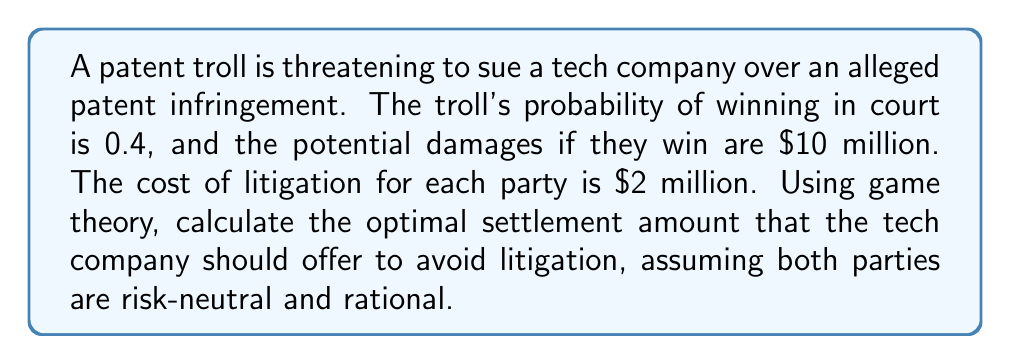Can you solve this math problem? Let's approach this step-by-step using game theory concepts:

1) First, we need to calculate the expected value of litigation for both parties:

   For the patent troll:
   $$ EV_{troll} = (0.4 \times \$10M) - \$2M = \$2M $$

   For the tech company:
   $$ EV_{company} = -(0.4 \times \$10M) - \$2M = -\$6M $$

2) The optimal settlement amount should be between these two values. Any amount less than $2M, the troll would prefer to litigate. Any amount more than $6M, the company would prefer to litigate.

3) Assuming both parties have equal bargaining power, we can use the Nash bargaining solution, which suggests that the optimal settlement would be at the midpoint between these two values:

   $$ Settlement = \frac{EV_{troll} + |EV_{company}|}{2} $$

4) Plugging in the values:

   $$ Settlement = \frac{\$2M + \$6M}{2} = \frac{\$8M}{2} = \$4M $$

Therefore, the optimal settlement amount for the tech company to offer is $4 million.
Answer: $4 million 